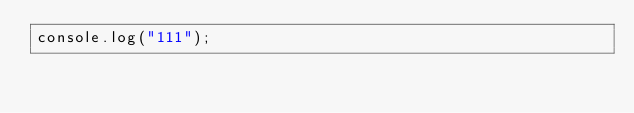<code> <loc_0><loc_0><loc_500><loc_500><_JavaScript_>console.log("111");</code> 